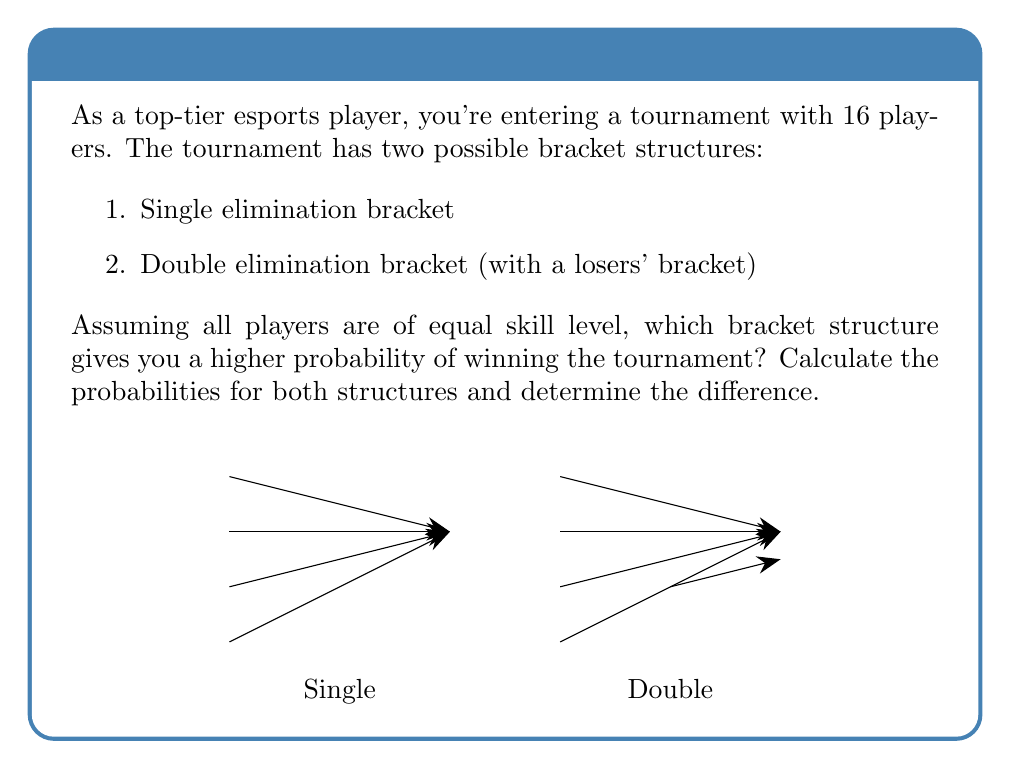What is the answer to this math problem? Let's calculate the probabilities for both bracket structures:

1. Single elimination bracket:
   - You need to win 4 matches in a row to win the tournament.
   - Probability of winning each match is 1/2 (assuming equal skill levels).
   - Probability of winning the tournament: $P_{single} = (\frac{1}{2})^4 = \frac{1}{16}$

2. Double elimination bracket:
   - To win through the winners' bracket, you need to win 4 matches: $(\frac{1}{2})^4 = \frac{1}{16}$
   - If you lose once, you can still win through the losers' bracket:
     * Probability of losing exactly one match in the first 3 rounds: $3 \cdot (\frac{1}{2})^3 \cdot \frac{1}{2} = \frac{3}{16}$
     * Then you need to win 3 matches in the losers' bracket and 2 in the finals: $(\frac{1}{2})^5 = \frac{1}{32}$
   - Total probability for the losers' bracket path: $\frac{3}{16} \cdot \frac{1}{32} = \frac{3}{512}$
   - Probability of winning the tournament: $P_{double} = \frac{1}{16} + \frac{3}{512} = \frac{32}{512} + \frac{3}{512} = \frac{35}{512}$

The difference in probabilities:
$$P_{double} - P_{single} = \frac{35}{512} - \frac{1}{16} = \frac{35}{512} - \frac{32}{512} = \frac{3}{512} \approx 0.00586$$

Therefore, the double elimination bracket gives you a higher probability of winning the tournament, with a difference of $\frac{3}{512}$ or about 0.586%.
Answer: Double elimination; $P_{double} = \frac{35}{512}$, $P_{single} = \frac{1}{16}$; Difference: $\frac{3}{512}$ 